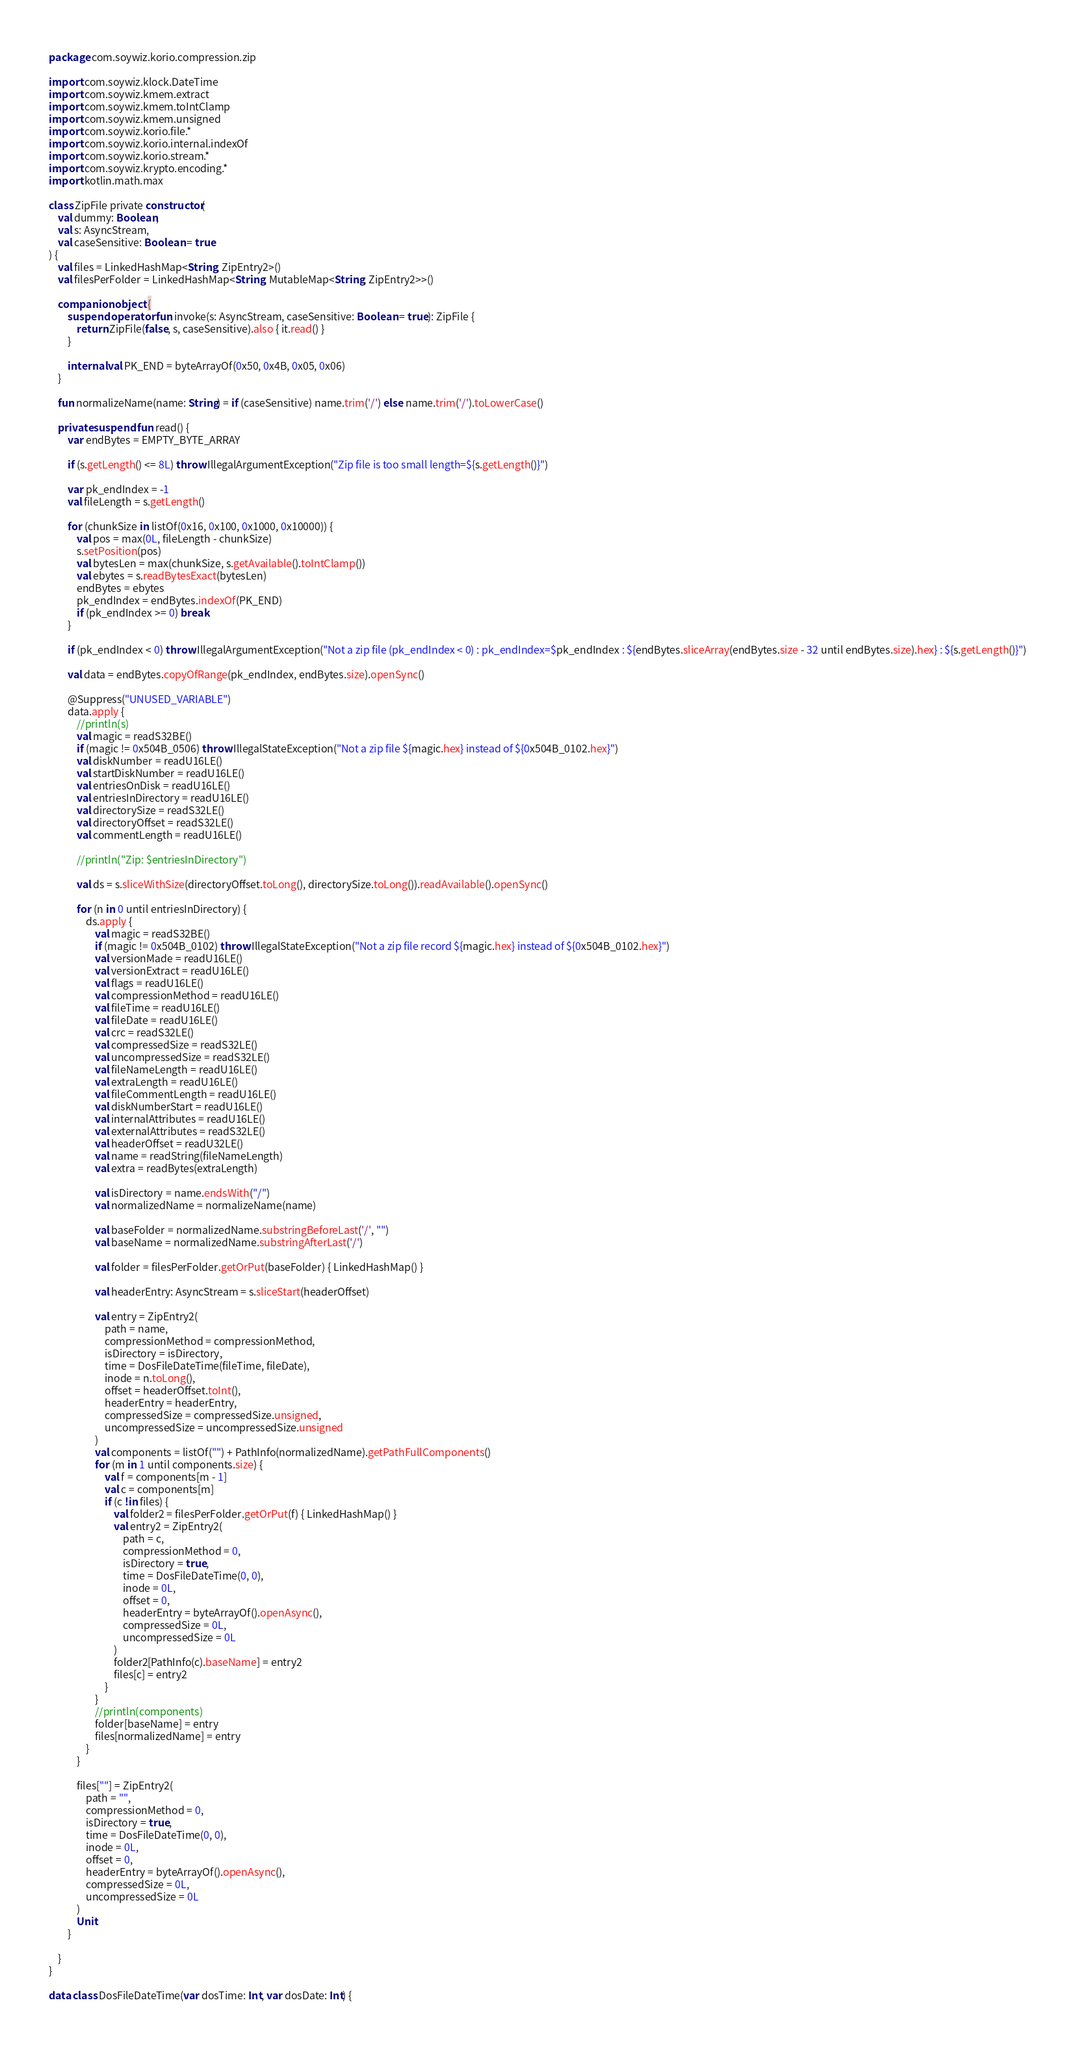<code> <loc_0><loc_0><loc_500><loc_500><_Kotlin_>package com.soywiz.korio.compression.zip

import com.soywiz.klock.DateTime
import com.soywiz.kmem.extract
import com.soywiz.kmem.toIntClamp
import com.soywiz.kmem.unsigned
import com.soywiz.korio.file.*
import com.soywiz.korio.internal.indexOf
import com.soywiz.korio.stream.*
import com.soywiz.krypto.encoding.*
import kotlin.math.max

class ZipFile private constructor(
    val dummy: Boolean,
    val s: AsyncStream,
    val caseSensitive: Boolean = true
) {
    val files = LinkedHashMap<String, ZipEntry2>()
    val filesPerFolder = LinkedHashMap<String, MutableMap<String, ZipEntry2>>()

    companion object {
        suspend operator fun invoke(s: AsyncStream, caseSensitive: Boolean = true): ZipFile {
            return ZipFile(false, s, caseSensitive).also { it.read() }
        }

        internal val PK_END = byteArrayOf(0x50, 0x4B, 0x05, 0x06)
    }

    fun normalizeName(name: String) = if (caseSensitive) name.trim('/') else name.trim('/').toLowerCase()

    private suspend fun read() {
        var endBytes = EMPTY_BYTE_ARRAY

        if (s.getLength() <= 8L) throw IllegalArgumentException("Zip file is too small length=${s.getLength()}")

        var pk_endIndex = -1
        val fileLength = s.getLength()

        for (chunkSize in listOf(0x16, 0x100, 0x1000, 0x10000)) {
            val pos = max(0L, fileLength - chunkSize)
            s.setPosition(pos)
            val bytesLen = max(chunkSize, s.getAvailable().toIntClamp())
            val ebytes = s.readBytesExact(bytesLen)
            endBytes = ebytes
            pk_endIndex = endBytes.indexOf(PK_END)
            if (pk_endIndex >= 0) break
        }

        if (pk_endIndex < 0) throw IllegalArgumentException("Not a zip file (pk_endIndex < 0) : pk_endIndex=$pk_endIndex : ${endBytes.sliceArray(endBytes.size - 32 until endBytes.size).hex} : ${s.getLength()}")

        val data = endBytes.copyOfRange(pk_endIndex, endBytes.size).openSync()

        @Suppress("UNUSED_VARIABLE")
        data.apply {
            //println(s)
            val magic = readS32BE()
            if (magic != 0x504B_0506) throw IllegalStateException("Not a zip file ${magic.hex} instead of ${0x504B_0102.hex}")
            val diskNumber = readU16LE()
            val startDiskNumber = readU16LE()
            val entriesOnDisk = readU16LE()
            val entriesInDirectory = readU16LE()
            val directorySize = readS32LE()
            val directoryOffset = readS32LE()
            val commentLength = readU16LE()

            //println("Zip: $entriesInDirectory")

            val ds = s.sliceWithSize(directoryOffset.toLong(), directorySize.toLong()).readAvailable().openSync()

            for (n in 0 until entriesInDirectory) {
                ds.apply {
                    val magic = readS32BE()
                    if (magic != 0x504B_0102) throw IllegalStateException("Not a zip file record ${magic.hex} instead of ${0x504B_0102.hex}")
                    val versionMade = readU16LE()
                    val versionExtract = readU16LE()
                    val flags = readU16LE()
                    val compressionMethod = readU16LE()
                    val fileTime = readU16LE()
                    val fileDate = readU16LE()
                    val crc = readS32LE()
                    val compressedSize = readS32LE()
                    val uncompressedSize = readS32LE()
                    val fileNameLength = readU16LE()
                    val extraLength = readU16LE()
                    val fileCommentLength = readU16LE()
                    val diskNumberStart = readU16LE()
                    val internalAttributes = readU16LE()
                    val externalAttributes = readS32LE()
                    val headerOffset = readU32LE()
                    val name = readString(fileNameLength)
                    val extra = readBytes(extraLength)

                    val isDirectory = name.endsWith("/")
                    val normalizedName = normalizeName(name)

                    val baseFolder = normalizedName.substringBeforeLast('/', "")
                    val baseName = normalizedName.substringAfterLast('/')

                    val folder = filesPerFolder.getOrPut(baseFolder) { LinkedHashMap() }

                    val headerEntry: AsyncStream = s.sliceStart(headerOffset)

                    val entry = ZipEntry2(
                        path = name,
                        compressionMethod = compressionMethod,
                        isDirectory = isDirectory,
                        time = DosFileDateTime(fileTime, fileDate),
                        inode = n.toLong(),
                        offset = headerOffset.toInt(),
                        headerEntry = headerEntry,
                        compressedSize = compressedSize.unsigned,
                        uncompressedSize = uncompressedSize.unsigned
                    )
                    val components = listOf("") + PathInfo(normalizedName).getPathFullComponents()
                    for (m in 1 until components.size) {
                        val f = components[m - 1]
                        val c = components[m]
                        if (c !in files) {
                            val folder2 = filesPerFolder.getOrPut(f) { LinkedHashMap() }
                            val entry2 = ZipEntry2(
                                path = c,
                                compressionMethod = 0,
                                isDirectory = true,
                                time = DosFileDateTime(0, 0),
                                inode = 0L,
                                offset = 0,
                                headerEntry = byteArrayOf().openAsync(),
                                compressedSize = 0L,
                                uncompressedSize = 0L
                            )
                            folder2[PathInfo(c).baseName] = entry2
                            files[c] = entry2
                        }
                    }
                    //println(components)
                    folder[baseName] = entry
                    files[normalizedName] = entry
                }
            }

            files[""] = ZipEntry2(
                path = "",
                compressionMethod = 0,
                isDirectory = true,
                time = DosFileDateTime(0, 0),
                inode = 0L,
                offset = 0,
                headerEntry = byteArrayOf().openAsync(),
                compressedSize = 0L,
                uncompressedSize = 0L
            )
            Unit
        }

    }
}

data class DosFileDateTime(var dosTime: Int, var dosDate: Int) {</code> 